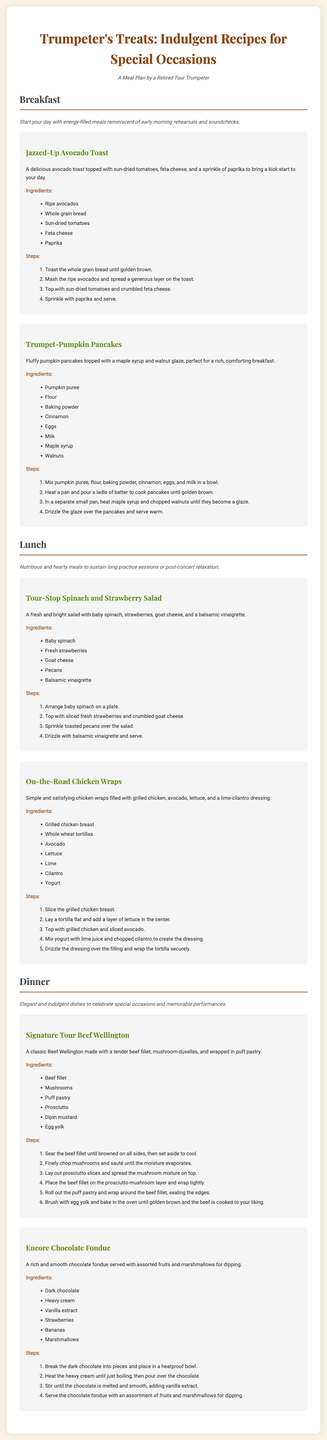What is the title of the document? The title is prominently displayed at the top of the document.
Answer: Trumpeter's Treats: Indulgent Recipes for Special Occasions How many breakfast recipes are included? The document lists two breakfast recipes under the Breakfast section.
Answer: 2 What is the main ingredient in Trumpet-Pumpkin Pancakes? The main ingredient is listed first in the ingredients list.
Answer: Pumpkin puree What type of dressing is used in the Tour-Stop Spinach and Strawberry Salad? The type of dressing is mentioned in the salad description.
Answer: Balsamic vinaigrette What dish is referred to as the main course for dinner? The main course is highlighted in the Dinner section of the document.
Answer: Signature Tour Beef Wellington Which dessert is offered in the dinner section? The dessert is the last dish mentioned in the Dinner section.
Answer: Encore Chocolate Fondue What is a key ingredient in the Encore Chocolate Fondue? The key ingredient is listed first in the ingredients for the dessert.
Answer: Dark chocolate What is the preparation method for the Jazzed-Up Avocado Toast? The method is described in the steps section for the recipe.
Answer: Toasting and layering ingredients 